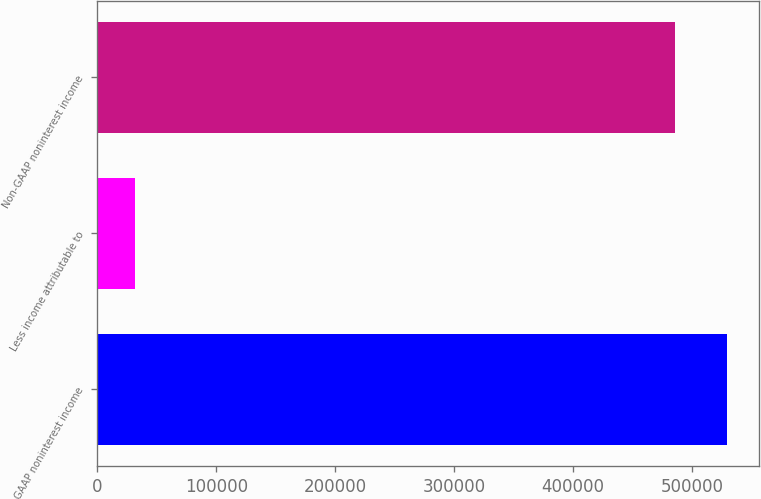Convert chart to OTSL. <chart><loc_0><loc_0><loc_500><loc_500><bar_chart><fcel>GAAP noninterest income<fcel>Less income attributable to<fcel>Non-GAAP noninterest income<nl><fcel>529270<fcel>31736<fcel>485164<nl></chart> 